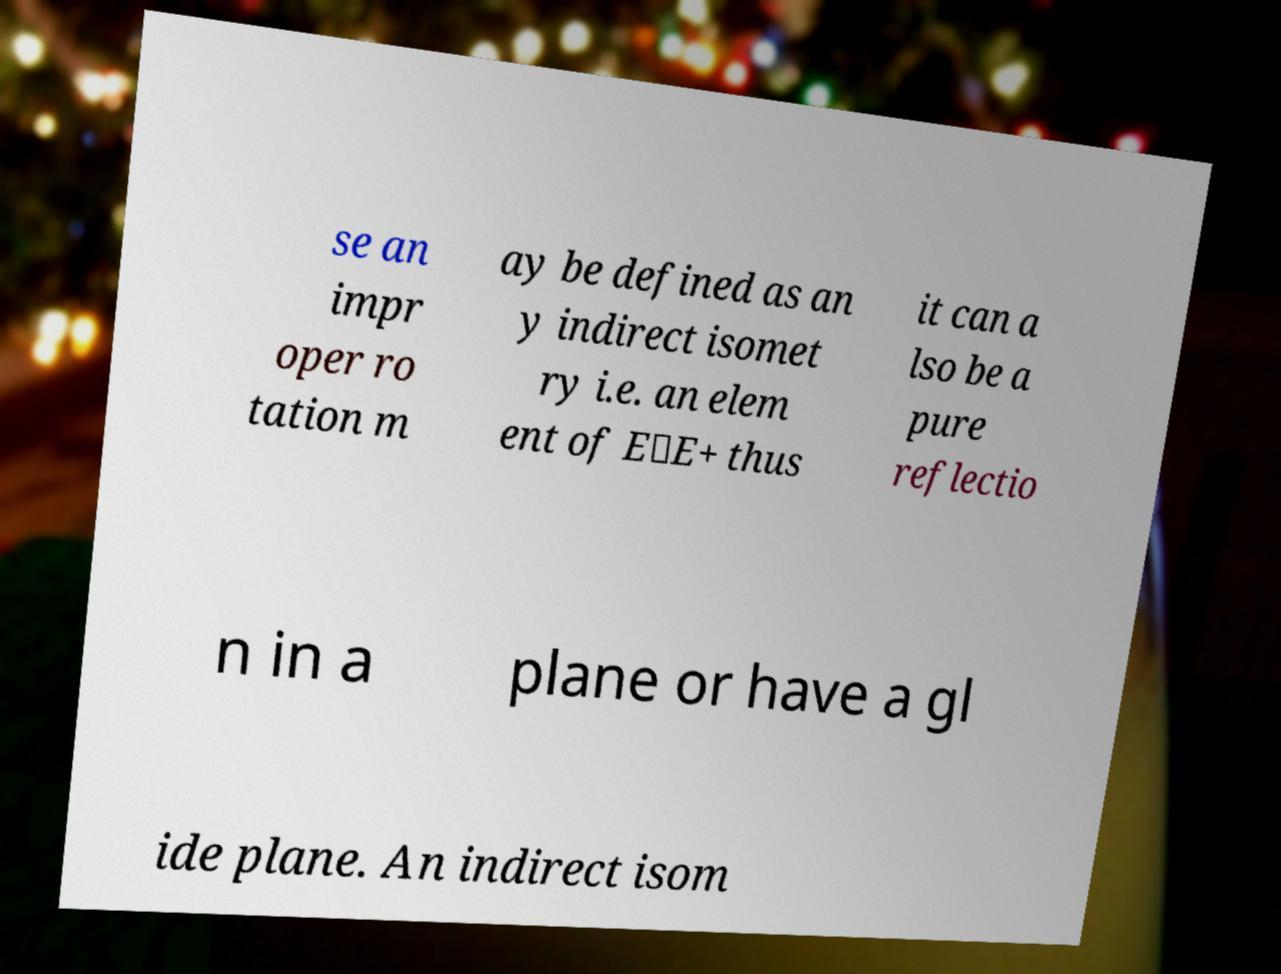Can you accurately transcribe the text from the provided image for me? se an impr oper ro tation m ay be defined as an y indirect isomet ry i.e. an elem ent of E\E+ thus it can a lso be a pure reflectio n in a plane or have a gl ide plane. An indirect isom 